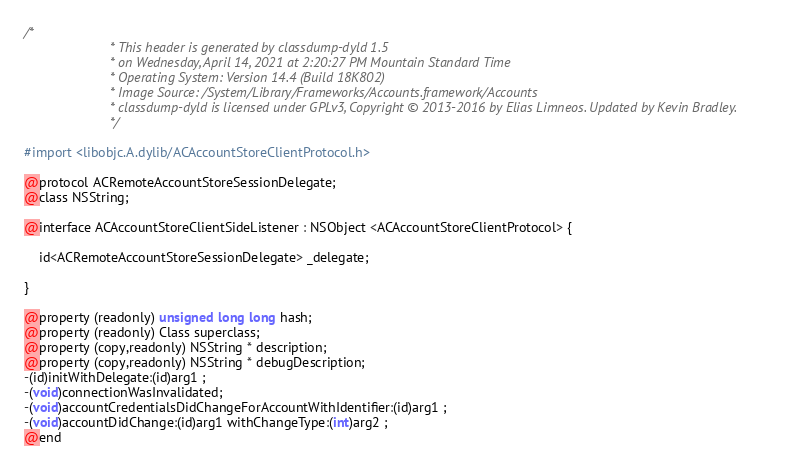Convert code to text. <code><loc_0><loc_0><loc_500><loc_500><_C_>/*
                       * This header is generated by classdump-dyld 1.5
                       * on Wednesday, April 14, 2021 at 2:20:27 PM Mountain Standard Time
                       * Operating System: Version 14.4 (Build 18K802)
                       * Image Source: /System/Library/Frameworks/Accounts.framework/Accounts
                       * classdump-dyld is licensed under GPLv3, Copyright © 2013-2016 by Elias Limneos. Updated by Kevin Bradley.
                       */

#import <libobjc.A.dylib/ACAccountStoreClientProtocol.h>

@protocol ACRemoteAccountStoreSessionDelegate;
@class NSString;

@interface ACAccountStoreClientSideListener : NSObject <ACAccountStoreClientProtocol> {

	id<ACRemoteAccountStoreSessionDelegate> _delegate;

}

@property (readonly) unsigned long long hash; 
@property (readonly) Class superclass; 
@property (copy,readonly) NSString * description; 
@property (copy,readonly) NSString * debugDescription; 
-(id)initWithDelegate:(id)arg1 ;
-(void)connectionWasInvalidated;
-(void)accountCredentialsDidChangeForAccountWithIdentifier:(id)arg1 ;
-(void)accountDidChange:(id)arg1 withChangeType:(int)arg2 ;
@end

</code> 